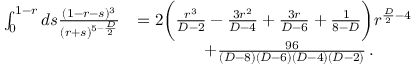<formula> <loc_0><loc_0><loc_500><loc_500>\begin{array} { r l } { \int _ { 0 } ^ { 1 - r } d s \frac { ( 1 - r - s ) ^ { 3 } } { ( r + s ) ^ { 5 - \frac { D } { 2 } } } } & { = 2 \left ( \frac { r ^ { 3 } } { D - 2 } - \frac { 3 r ^ { 2 } } { D - 4 } + \frac { 3 r } { D - 6 } + \frac { 1 } { 8 - D } \right ) r ^ { \frac { D } { 2 } - 4 } } \\ & { \quad + \frac { 9 6 } { ( D - 8 ) ( D - 6 ) ( D - 4 ) ( D - 2 ) } \, . } \end{array}</formula> 